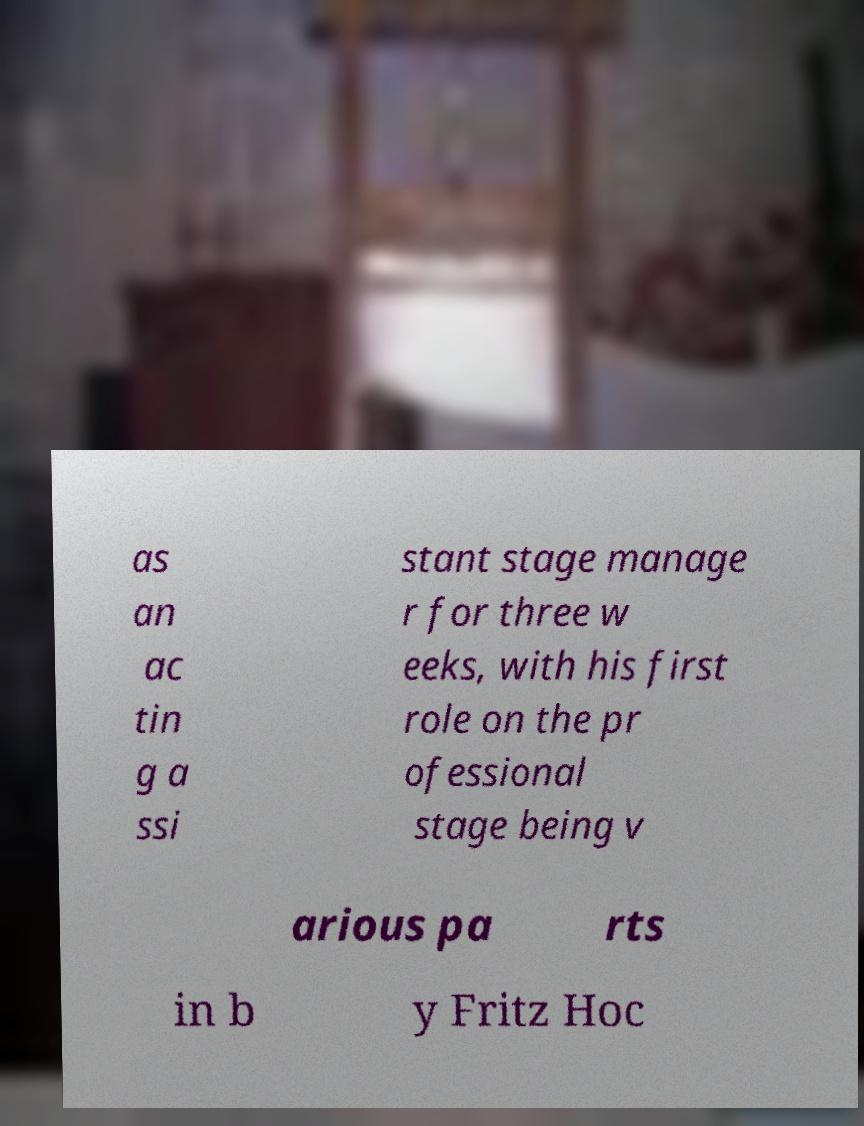Can you read and provide the text displayed in the image?This photo seems to have some interesting text. Can you extract and type it out for me? as an ac tin g a ssi stant stage manage r for three w eeks, with his first role on the pr ofessional stage being v arious pa rts in b y Fritz Hoc 